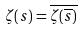Convert formula to latex. <formula><loc_0><loc_0><loc_500><loc_500>\zeta ( s ) = \overline { \zeta ( \overline { s } ) }</formula> 